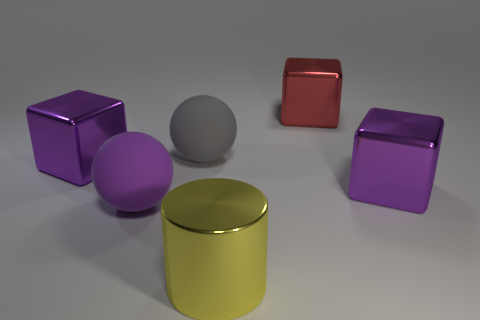Subtract all large purple metallic cubes. How many cubes are left? 1 Add 3 purple things. How many objects exist? 9 Subtract all cylinders. How many objects are left? 5 Subtract 1 cylinders. How many cylinders are left? 0 Subtract all cyan spheres. How many purple blocks are left? 2 Add 1 large things. How many large things are left? 7 Add 4 cylinders. How many cylinders exist? 5 Subtract all red blocks. How many blocks are left? 2 Subtract 0 cyan balls. How many objects are left? 6 Subtract all blue blocks. Subtract all yellow cylinders. How many blocks are left? 3 